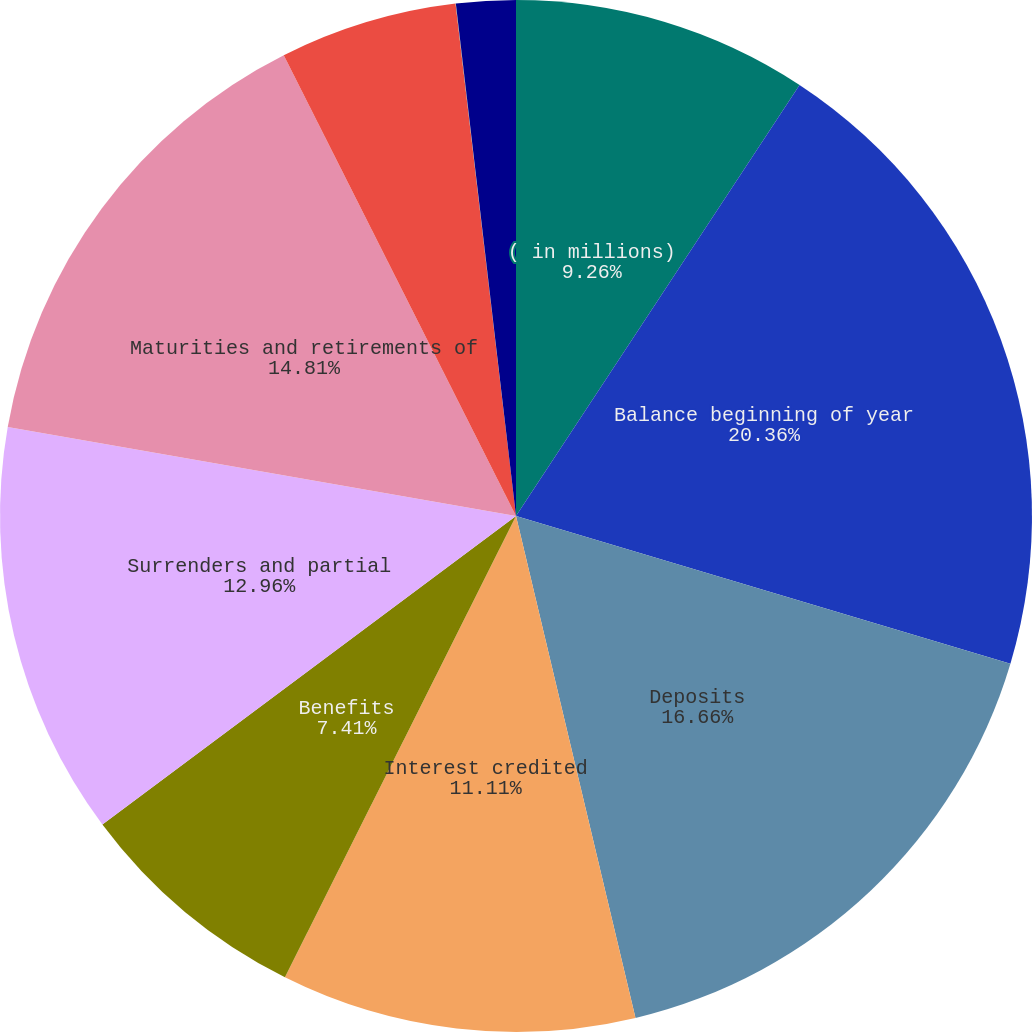<chart> <loc_0><loc_0><loc_500><loc_500><pie_chart><fcel>( in millions)<fcel>Balance beginning of year<fcel>Deposits<fcel>Interest credited<fcel>Benefits<fcel>Surrenders and partial<fcel>Maturities and retirements of<fcel>Contract charges<fcel>Net transfers from separate<fcel>Fair value hedge adjustments<nl><fcel>9.26%<fcel>20.36%<fcel>16.66%<fcel>11.11%<fcel>7.41%<fcel>12.96%<fcel>14.81%<fcel>5.56%<fcel>0.01%<fcel>1.86%<nl></chart> 